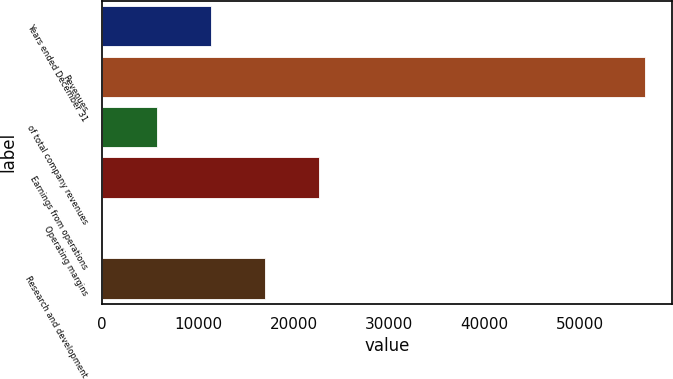Convert chart. <chart><loc_0><loc_0><loc_500><loc_500><bar_chart><fcel>Years ended December 31<fcel>Revenues<fcel>of total company revenues<fcel>Earnings from operations<fcel>Operating margins<fcel>Research and development<nl><fcel>11353.5<fcel>56729<fcel>5681.54<fcel>22697.4<fcel>9.6<fcel>17025.4<nl></chart> 